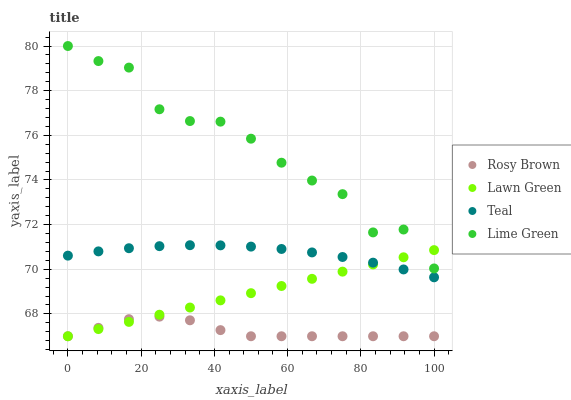Does Rosy Brown have the minimum area under the curve?
Answer yes or no. Yes. Does Lime Green have the maximum area under the curve?
Answer yes or no. Yes. Does Lime Green have the minimum area under the curve?
Answer yes or no. No. Does Rosy Brown have the maximum area under the curve?
Answer yes or no. No. Is Lawn Green the smoothest?
Answer yes or no. Yes. Is Lime Green the roughest?
Answer yes or no. Yes. Is Rosy Brown the smoothest?
Answer yes or no. No. Is Rosy Brown the roughest?
Answer yes or no. No. Does Lawn Green have the lowest value?
Answer yes or no. Yes. Does Lime Green have the lowest value?
Answer yes or no. No. Does Lime Green have the highest value?
Answer yes or no. Yes. Does Rosy Brown have the highest value?
Answer yes or no. No. Is Rosy Brown less than Teal?
Answer yes or no. Yes. Is Teal greater than Rosy Brown?
Answer yes or no. Yes. Does Lawn Green intersect Rosy Brown?
Answer yes or no. Yes. Is Lawn Green less than Rosy Brown?
Answer yes or no. No. Is Lawn Green greater than Rosy Brown?
Answer yes or no. No. Does Rosy Brown intersect Teal?
Answer yes or no. No. 